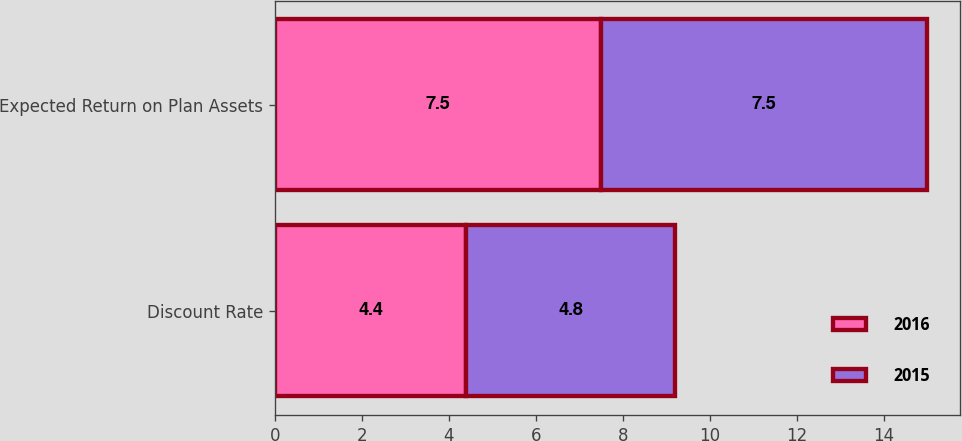Convert chart to OTSL. <chart><loc_0><loc_0><loc_500><loc_500><stacked_bar_chart><ecel><fcel>Discount Rate<fcel>Expected Return on Plan Assets<nl><fcel>2016<fcel>4.4<fcel>7.5<nl><fcel>2015<fcel>4.8<fcel>7.5<nl></chart> 